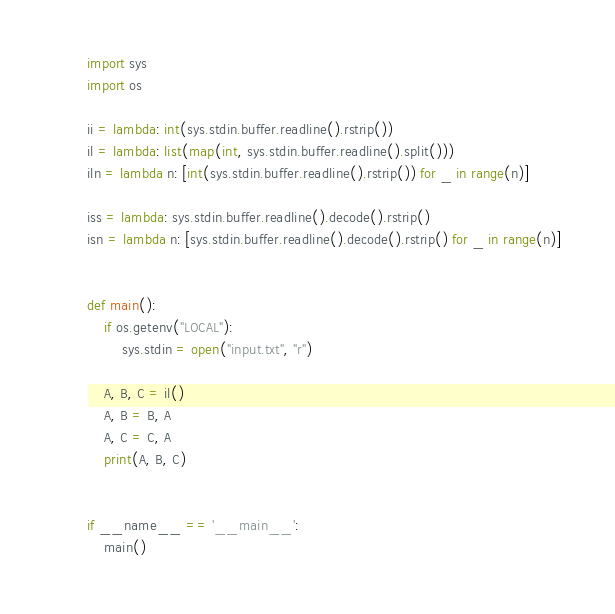<code> <loc_0><loc_0><loc_500><loc_500><_Python_>import sys
import os

ii = lambda: int(sys.stdin.buffer.readline().rstrip())
il = lambda: list(map(int, sys.stdin.buffer.readline().split()))
iln = lambda n: [int(sys.stdin.buffer.readline().rstrip()) for _ in range(n)]

iss = lambda: sys.stdin.buffer.readline().decode().rstrip()
isn = lambda n: [sys.stdin.buffer.readline().decode().rstrip() for _ in range(n)]


def main():
    if os.getenv("LOCAL"):
        sys.stdin = open("input.txt", "r")

    A, B, C = il()
    A, B = B, A
    A, C = C, A
    print(A, B, C)


if __name__ == '__main__':
    main()
</code> 